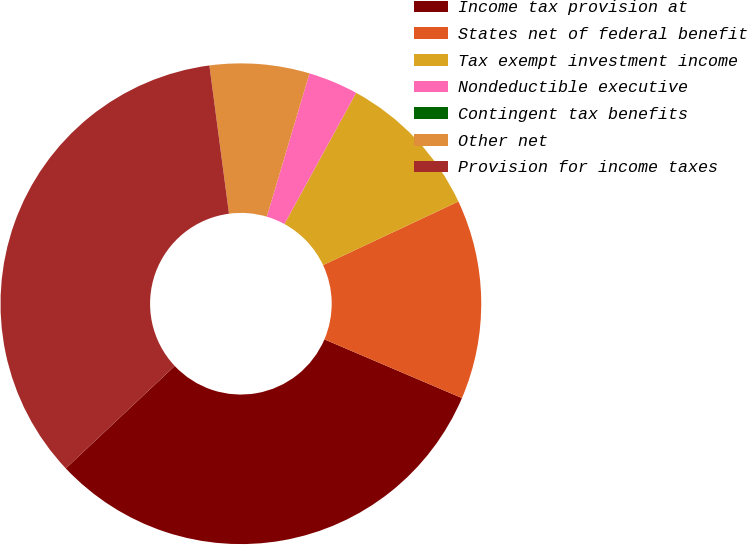<chart> <loc_0><loc_0><loc_500><loc_500><pie_chart><fcel>Income tax provision at<fcel>States net of federal benefit<fcel>Tax exempt investment income<fcel>Nondeductible executive<fcel>Contingent tax benefits<fcel>Other net<fcel>Provision for income taxes<nl><fcel>31.57%<fcel>13.41%<fcel>10.05%<fcel>3.35%<fcel>0.0%<fcel>6.7%<fcel>34.92%<nl></chart> 